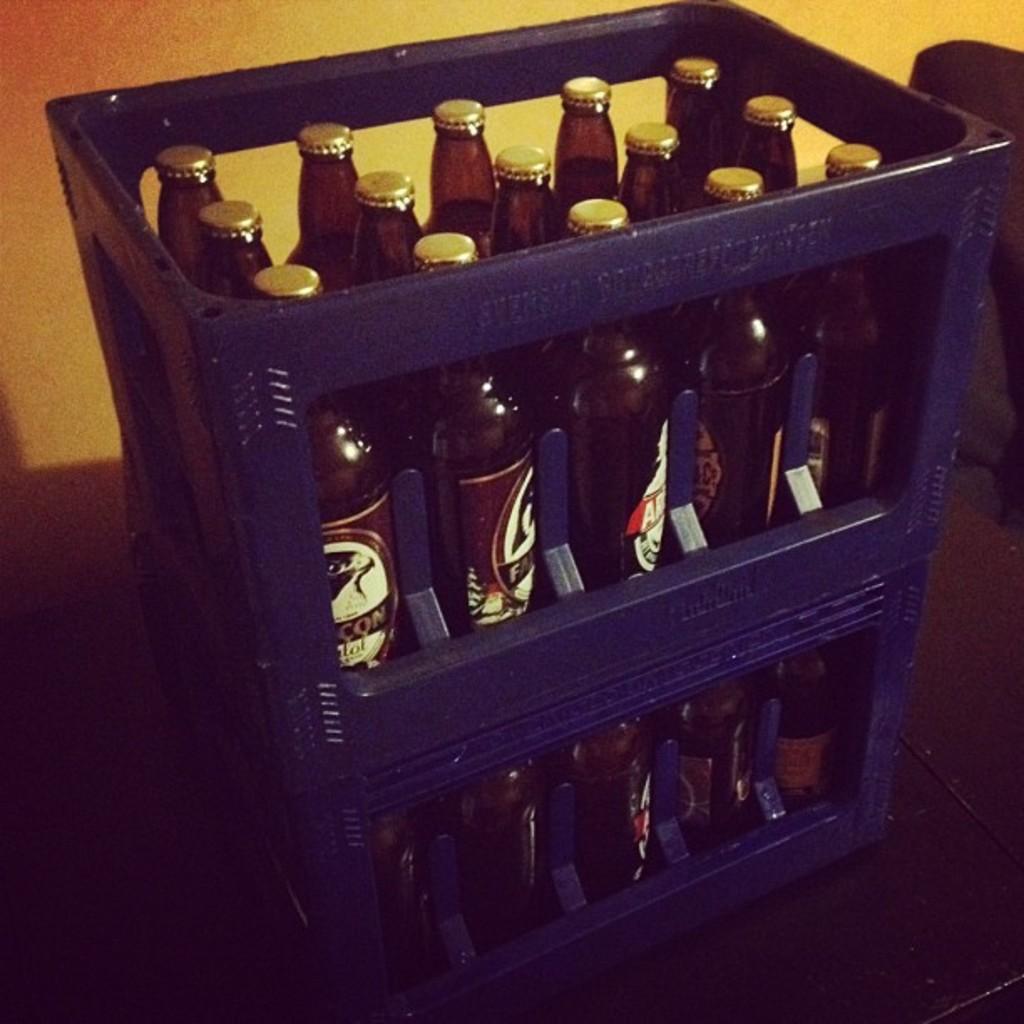How would you summarize this image in a sentence or two? These days are filled with bottles. 